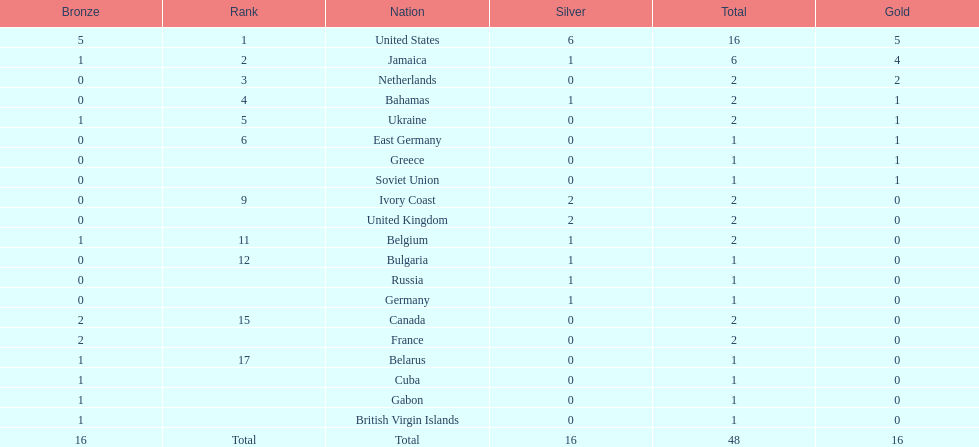What country won more gold medals than any other? United States. 